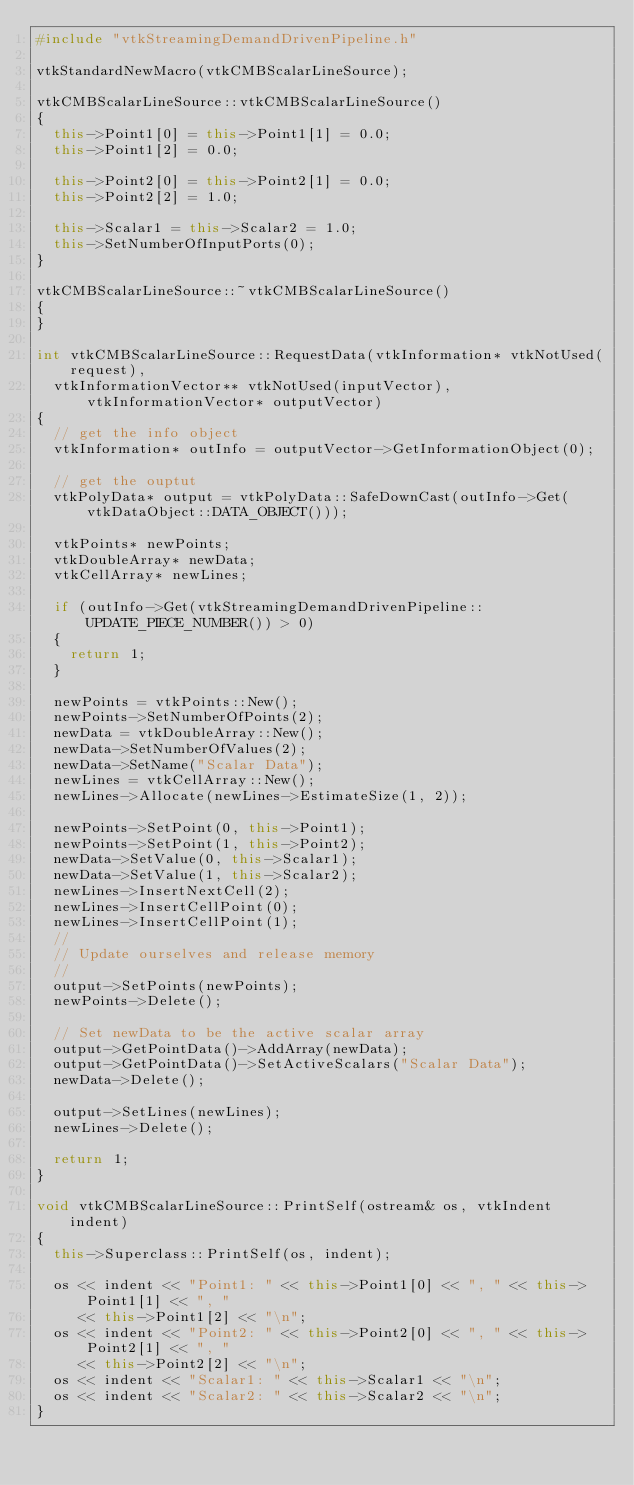<code> <loc_0><loc_0><loc_500><loc_500><_C++_>#include "vtkStreamingDemandDrivenPipeline.h"

vtkStandardNewMacro(vtkCMBScalarLineSource);

vtkCMBScalarLineSource::vtkCMBScalarLineSource()
{
  this->Point1[0] = this->Point1[1] = 0.0;
  this->Point1[2] = 0.0;

  this->Point2[0] = this->Point2[1] = 0.0;
  this->Point2[2] = 1.0;

  this->Scalar1 = this->Scalar2 = 1.0;
  this->SetNumberOfInputPorts(0);
}

vtkCMBScalarLineSource::~vtkCMBScalarLineSource()
{
}

int vtkCMBScalarLineSource::RequestData(vtkInformation* vtkNotUsed(request),
  vtkInformationVector** vtkNotUsed(inputVector), vtkInformationVector* outputVector)
{
  // get the info object
  vtkInformation* outInfo = outputVector->GetInformationObject(0);

  // get the ouptut
  vtkPolyData* output = vtkPolyData::SafeDownCast(outInfo->Get(vtkDataObject::DATA_OBJECT()));

  vtkPoints* newPoints;
  vtkDoubleArray* newData;
  vtkCellArray* newLines;

  if (outInfo->Get(vtkStreamingDemandDrivenPipeline::UPDATE_PIECE_NUMBER()) > 0)
  {
    return 1;
  }

  newPoints = vtkPoints::New();
  newPoints->SetNumberOfPoints(2);
  newData = vtkDoubleArray::New();
  newData->SetNumberOfValues(2);
  newData->SetName("Scalar Data");
  newLines = vtkCellArray::New();
  newLines->Allocate(newLines->EstimateSize(1, 2));

  newPoints->SetPoint(0, this->Point1);
  newPoints->SetPoint(1, this->Point2);
  newData->SetValue(0, this->Scalar1);
  newData->SetValue(1, this->Scalar2);
  newLines->InsertNextCell(2);
  newLines->InsertCellPoint(0);
  newLines->InsertCellPoint(1);
  //
  // Update ourselves and release memory
  //
  output->SetPoints(newPoints);
  newPoints->Delete();

  // Set newData to be the active scalar array
  output->GetPointData()->AddArray(newData);
  output->GetPointData()->SetActiveScalars("Scalar Data");
  newData->Delete();

  output->SetLines(newLines);
  newLines->Delete();

  return 1;
}

void vtkCMBScalarLineSource::PrintSelf(ostream& os, vtkIndent indent)
{
  this->Superclass::PrintSelf(os, indent);

  os << indent << "Point1: " << this->Point1[0] << ", " << this->Point1[1] << ", "
     << this->Point1[2] << "\n";
  os << indent << "Point2: " << this->Point2[0] << ", " << this->Point2[1] << ", "
     << this->Point2[2] << "\n";
  os << indent << "Scalar1: " << this->Scalar1 << "\n";
  os << indent << "Scalar2: " << this->Scalar2 << "\n";
}
</code> 